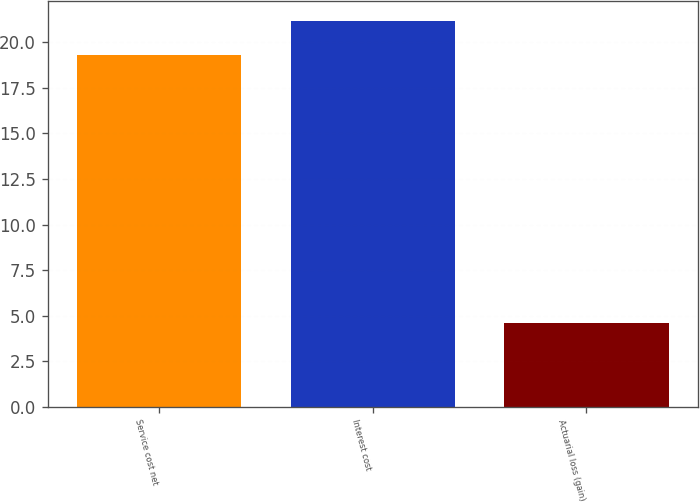Convert chart. <chart><loc_0><loc_0><loc_500><loc_500><bar_chart><fcel>Service cost net<fcel>Interest cost<fcel>Actuarial loss (gain)<nl><fcel>19.3<fcel>21.2<fcel>4.6<nl></chart> 